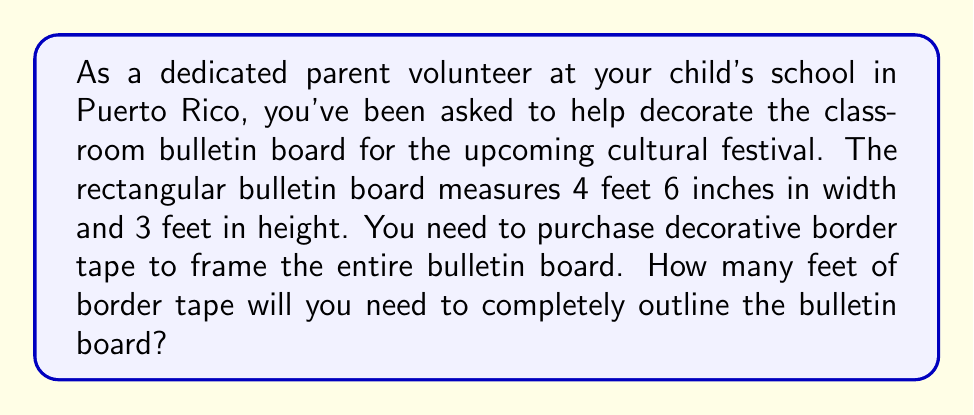Show me your answer to this math problem. Let's approach this step-by-step:

1) First, we need to identify the shape of the bulletin board. It's rectangular, which means we need to find the perimeter of a rectangle.

2) The formula for the perimeter of a rectangle is:
   $$P = 2l + 2w$$
   where $P$ is the perimeter, $l$ is the length (height in this case), and $w$ is the width.

3) We're given the following measurements:
   - Width (w) = 4 feet 6 inches
   - Height (l) = 3 feet

4) Before we can use the formula, we need to convert all measurements to the same unit. Let's convert everything to feet:
   - 4 feet 6 inches = 4.5 feet (since 6 inches is half a foot)
   - 3 feet remains as is

5) Now we can plug these values into our formula:
   $$P = 2(3) + 2(4.5)$$

6) Let's solve:
   $$P = 6 + 9 = 15$$

Therefore, the perimeter of the bulletin board is 15 feet.
Answer: You will need 15 feet of border tape to completely outline the bulletin board. 